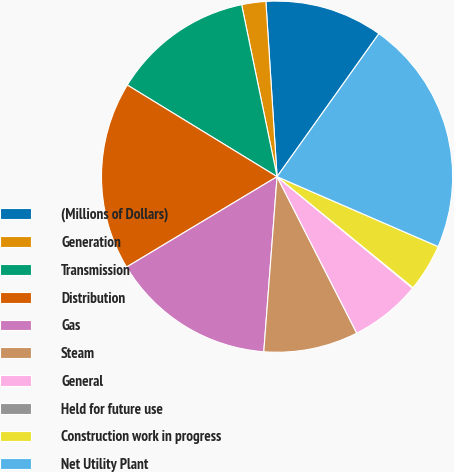Convert chart. <chart><loc_0><loc_0><loc_500><loc_500><pie_chart><fcel>(Millions of Dollars)<fcel>Generation<fcel>Transmission<fcel>Distribution<fcel>Gas<fcel>Steam<fcel>General<fcel>Held for future use<fcel>Construction work in progress<fcel>Net Utility Plant<nl><fcel>10.86%<fcel>2.22%<fcel>13.02%<fcel>17.34%<fcel>15.18%<fcel>8.7%<fcel>6.54%<fcel>0.06%<fcel>4.38%<fcel>21.66%<nl></chart> 